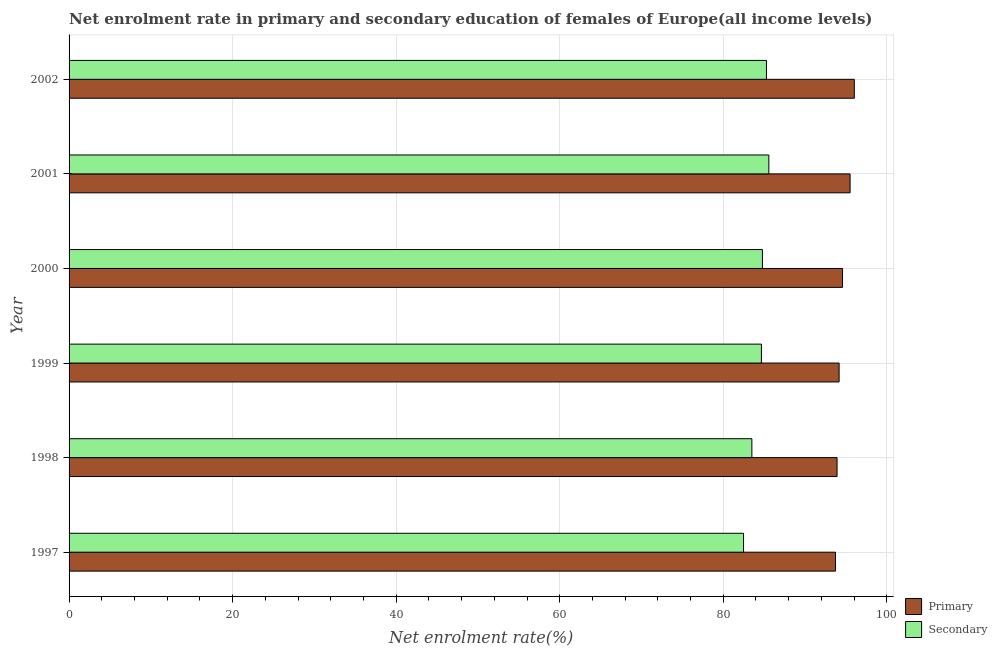How many different coloured bars are there?
Your response must be concise. 2. How many bars are there on the 4th tick from the top?
Your response must be concise. 2. In how many cases, is the number of bars for a given year not equal to the number of legend labels?
Your answer should be very brief. 0. What is the enrollment rate in secondary education in 2001?
Your answer should be compact. 85.58. Across all years, what is the maximum enrollment rate in primary education?
Make the answer very short. 96.03. Across all years, what is the minimum enrollment rate in primary education?
Make the answer very short. 93.73. In which year was the enrollment rate in primary education maximum?
Your answer should be compact. 2002. What is the total enrollment rate in primary education in the graph?
Offer a very short reply. 567.94. What is the difference between the enrollment rate in secondary education in 1997 and that in 1998?
Your answer should be very brief. -1.02. What is the difference between the enrollment rate in secondary education in 2001 and the enrollment rate in primary education in 1997?
Make the answer very short. -8.15. What is the average enrollment rate in secondary education per year?
Your answer should be very brief. 84.38. In the year 1997, what is the difference between the enrollment rate in secondary education and enrollment rate in primary education?
Your response must be concise. -11.24. What is the ratio of the enrollment rate in secondary education in 1999 to that in 2002?
Keep it short and to the point. 0.99. What is the difference between the highest and the second highest enrollment rate in primary education?
Provide a short and direct response. 0.52. What is the difference between the highest and the lowest enrollment rate in secondary education?
Make the answer very short. 3.09. In how many years, is the enrollment rate in primary education greater than the average enrollment rate in primary education taken over all years?
Your answer should be compact. 2. Is the sum of the enrollment rate in secondary education in 2000 and 2001 greater than the maximum enrollment rate in primary education across all years?
Make the answer very short. Yes. What does the 2nd bar from the top in 1997 represents?
Provide a succinct answer. Primary. What does the 2nd bar from the bottom in 2001 represents?
Provide a succinct answer. Secondary. How many bars are there?
Make the answer very short. 12. Are all the bars in the graph horizontal?
Your answer should be compact. Yes. How are the legend labels stacked?
Give a very brief answer. Vertical. What is the title of the graph?
Provide a succinct answer. Net enrolment rate in primary and secondary education of females of Europe(all income levels). What is the label or title of the X-axis?
Keep it short and to the point. Net enrolment rate(%). What is the Net enrolment rate(%) of Primary in 1997?
Offer a terse response. 93.73. What is the Net enrolment rate(%) of Secondary in 1997?
Your response must be concise. 82.48. What is the Net enrolment rate(%) in Primary in 1998?
Offer a very short reply. 93.92. What is the Net enrolment rate(%) in Secondary in 1998?
Make the answer very short. 83.5. What is the Net enrolment rate(%) of Primary in 1999?
Give a very brief answer. 94.17. What is the Net enrolment rate(%) of Secondary in 1999?
Ensure brevity in your answer.  84.67. What is the Net enrolment rate(%) in Primary in 2000?
Make the answer very short. 94.59. What is the Net enrolment rate(%) in Secondary in 2000?
Make the answer very short. 84.79. What is the Net enrolment rate(%) in Primary in 2001?
Your answer should be very brief. 95.51. What is the Net enrolment rate(%) of Secondary in 2001?
Give a very brief answer. 85.58. What is the Net enrolment rate(%) of Primary in 2002?
Offer a terse response. 96.03. What is the Net enrolment rate(%) in Secondary in 2002?
Your response must be concise. 85.29. Across all years, what is the maximum Net enrolment rate(%) in Primary?
Ensure brevity in your answer.  96.03. Across all years, what is the maximum Net enrolment rate(%) of Secondary?
Keep it short and to the point. 85.58. Across all years, what is the minimum Net enrolment rate(%) in Primary?
Provide a succinct answer. 93.73. Across all years, what is the minimum Net enrolment rate(%) in Secondary?
Offer a terse response. 82.48. What is the total Net enrolment rate(%) of Primary in the graph?
Offer a very short reply. 567.94. What is the total Net enrolment rate(%) of Secondary in the graph?
Offer a very short reply. 506.3. What is the difference between the Net enrolment rate(%) of Primary in 1997 and that in 1998?
Offer a very short reply. -0.19. What is the difference between the Net enrolment rate(%) of Secondary in 1997 and that in 1998?
Provide a succinct answer. -1.02. What is the difference between the Net enrolment rate(%) of Primary in 1997 and that in 1999?
Offer a terse response. -0.44. What is the difference between the Net enrolment rate(%) in Secondary in 1997 and that in 1999?
Your answer should be very brief. -2.19. What is the difference between the Net enrolment rate(%) of Primary in 1997 and that in 2000?
Keep it short and to the point. -0.86. What is the difference between the Net enrolment rate(%) in Secondary in 1997 and that in 2000?
Your answer should be compact. -2.31. What is the difference between the Net enrolment rate(%) in Primary in 1997 and that in 2001?
Offer a very short reply. -1.78. What is the difference between the Net enrolment rate(%) of Secondary in 1997 and that in 2001?
Offer a terse response. -3.09. What is the difference between the Net enrolment rate(%) in Primary in 1997 and that in 2002?
Provide a succinct answer. -2.3. What is the difference between the Net enrolment rate(%) of Secondary in 1997 and that in 2002?
Your answer should be compact. -2.8. What is the difference between the Net enrolment rate(%) of Primary in 1998 and that in 1999?
Your answer should be compact. -0.25. What is the difference between the Net enrolment rate(%) in Secondary in 1998 and that in 1999?
Ensure brevity in your answer.  -1.17. What is the difference between the Net enrolment rate(%) in Primary in 1998 and that in 2000?
Your answer should be very brief. -0.67. What is the difference between the Net enrolment rate(%) of Secondary in 1998 and that in 2000?
Your answer should be compact. -1.29. What is the difference between the Net enrolment rate(%) of Primary in 1998 and that in 2001?
Ensure brevity in your answer.  -1.59. What is the difference between the Net enrolment rate(%) in Secondary in 1998 and that in 2001?
Ensure brevity in your answer.  -2.08. What is the difference between the Net enrolment rate(%) in Primary in 1998 and that in 2002?
Give a very brief answer. -2.11. What is the difference between the Net enrolment rate(%) of Secondary in 1998 and that in 2002?
Your response must be concise. -1.79. What is the difference between the Net enrolment rate(%) in Primary in 1999 and that in 2000?
Give a very brief answer. -0.42. What is the difference between the Net enrolment rate(%) of Secondary in 1999 and that in 2000?
Your answer should be compact. -0.12. What is the difference between the Net enrolment rate(%) in Primary in 1999 and that in 2001?
Keep it short and to the point. -1.34. What is the difference between the Net enrolment rate(%) in Secondary in 1999 and that in 2001?
Offer a terse response. -0.91. What is the difference between the Net enrolment rate(%) of Primary in 1999 and that in 2002?
Your answer should be compact. -1.86. What is the difference between the Net enrolment rate(%) of Secondary in 1999 and that in 2002?
Offer a terse response. -0.62. What is the difference between the Net enrolment rate(%) of Primary in 2000 and that in 2001?
Provide a short and direct response. -0.93. What is the difference between the Net enrolment rate(%) in Secondary in 2000 and that in 2001?
Your answer should be compact. -0.79. What is the difference between the Net enrolment rate(%) in Primary in 2000 and that in 2002?
Offer a very short reply. -1.44. What is the difference between the Net enrolment rate(%) of Secondary in 2000 and that in 2002?
Give a very brief answer. -0.5. What is the difference between the Net enrolment rate(%) of Primary in 2001 and that in 2002?
Keep it short and to the point. -0.52. What is the difference between the Net enrolment rate(%) in Secondary in 2001 and that in 2002?
Ensure brevity in your answer.  0.29. What is the difference between the Net enrolment rate(%) of Primary in 1997 and the Net enrolment rate(%) of Secondary in 1998?
Provide a succinct answer. 10.23. What is the difference between the Net enrolment rate(%) in Primary in 1997 and the Net enrolment rate(%) in Secondary in 1999?
Give a very brief answer. 9.06. What is the difference between the Net enrolment rate(%) in Primary in 1997 and the Net enrolment rate(%) in Secondary in 2000?
Make the answer very short. 8.94. What is the difference between the Net enrolment rate(%) in Primary in 1997 and the Net enrolment rate(%) in Secondary in 2001?
Your answer should be very brief. 8.15. What is the difference between the Net enrolment rate(%) of Primary in 1997 and the Net enrolment rate(%) of Secondary in 2002?
Your response must be concise. 8.44. What is the difference between the Net enrolment rate(%) in Primary in 1998 and the Net enrolment rate(%) in Secondary in 1999?
Your response must be concise. 9.25. What is the difference between the Net enrolment rate(%) in Primary in 1998 and the Net enrolment rate(%) in Secondary in 2000?
Give a very brief answer. 9.13. What is the difference between the Net enrolment rate(%) of Primary in 1998 and the Net enrolment rate(%) of Secondary in 2001?
Give a very brief answer. 8.34. What is the difference between the Net enrolment rate(%) in Primary in 1998 and the Net enrolment rate(%) in Secondary in 2002?
Ensure brevity in your answer.  8.63. What is the difference between the Net enrolment rate(%) in Primary in 1999 and the Net enrolment rate(%) in Secondary in 2000?
Make the answer very short. 9.38. What is the difference between the Net enrolment rate(%) of Primary in 1999 and the Net enrolment rate(%) of Secondary in 2001?
Make the answer very short. 8.59. What is the difference between the Net enrolment rate(%) in Primary in 1999 and the Net enrolment rate(%) in Secondary in 2002?
Offer a terse response. 8.88. What is the difference between the Net enrolment rate(%) of Primary in 2000 and the Net enrolment rate(%) of Secondary in 2001?
Keep it short and to the point. 9.01. What is the difference between the Net enrolment rate(%) of Primary in 2000 and the Net enrolment rate(%) of Secondary in 2002?
Ensure brevity in your answer.  9.3. What is the difference between the Net enrolment rate(%) in Primary in 2001 and the Net enrolment rate(%) in Secondary in 2002?
Provide a short and direct response. 10.23. What is the average Net enrolment rate(%) of Primary per year?
Your answer should be very brief. 94.66. What is the average Net enrolment rate(%) in Secondary per year?
Offer a very short reply. 84.38. In the year 1997, what is the difference between the Net enrolment rate(%) in Primary and Net enrolment rate(%) in Secondary?
Your response must be concise. 11.25. In the year 1998, what is the difference between the Net enrolment rate(%) in Primary and Net enrolment rate(%) in Secondary?
Make the answer very short. 10.42. In the year 1999, what is the difference between the Net enrolment rate(%) in Primary and Net enrolment rate(%) in Secondary?
Provide a succinct answer. 9.5. In the year 2000, what is the difference between the Net enrolment rate(%) of Primary and Net enrolment rate(%) of Secondary?
Provide a succinct answer. 9.8. In the year 2001, what is the difference between the Net enrolment rate(%) in Primary and Net enrolment rate(%) in Secondary?
Ensure brevity in your answer.  9.94. In the year 2002, what is the difference between the Net enrolment rate(%) of Primary and Net enrolment rate(%) of Secondary?
Ensure brevity in your answer.  10.74. What is the ratio of the Net enrolment rate(%) of Primary in 1997 to that in 1999?
Provide a succinct answer. 1. What is the ratio of the Net enrolment rate(%) of Secondary in 1997 to that in 1999?
Give a very brief answer. 0.97. What is the ratio of the Net enrolment rate(%) in Primary in 1997 to that in 2000?
Give a very brief answer. 0.99. What is the ratio of the Net enrolment rate(%) of Secondary in 1997 to that in 2000?
Offer a very short reply. 0.97. What is the ratio of the Net enrolment rate(%) of Primary in 1997 to that in 2001?
Offer a terse response. 0.98. What is the ratio of the Net enrolment rate(%) in Secondary in 1997 to that in 2001?
Your response must be concise. 0.96. What is the ratio of the Net enrolment rate(%) in Primary in 1997 to that in 2002?
Your answer should be very brief. 0.98. What is the ratio of the Net enrolment rate(%) in Secondary in 1997 to that in 2002?
Offer a terse response. 0.97. What is the ratio of the Net enrolment rate(%) of Secondary in 1998 to that in 1999?
Provide a short and direct response. 0.99. What is the ratio of the Net enrolment rate(%) of Primary in 1998 to that in 2000?
Give a very brief answer. 0.99. What is the ratio of the Net enrolment rate(%) of Secondary in 1998 to that in 2000?
Provide a succinct answer. 0.98. What is the ratio of the Net enrolment rate(%) in Primary in 1998 to that in 2001?
Offer a terse response. 0.98. What is the ratio of the Net enrolment rate(%) in Secondary in 1998 to that in 2001?
Your answer should be very brief. 0.98. What is the ratio of the Net enrolment rate(%) of Primary in 1998 to that in 2002?
Ensure brevity in your answer.  0.98. What is the ratio of the Net enrolment rate(%) of Secondary in 1998 to that in 2002?
Provide a short and direct response. 0.98. What is the ratio of the Net enrolment rate(%) in Secondary in 1999 to that in 2000?
Make the answer very short. 1. What is the ratio of the Net enrolment rate(%) of Primary in 1999 to that in 2001?
Provide a short and direct response. 0.99. What is the ratio of the Net enrolment rate(%) in Secondary in 1999 to that in 2001?
Your response must be concise. 0.99. What is the ratio of the Net enrolment rate(%) of Primary in 1999 to that in 2002?
Make the answer very short. 0.98. What is the ratio of the Net enrolment rate(%) in Primary in 2000 to that in 2001?
Provide a succinct answer. 0.99. What is the ratio of the Net enrolment rate(%) of Secondary in 2000 to that in 2002?
Offer a terse response. 0.99. What is the difference between the highest and the second highest Net enrolment rate(%) of Primary?
Give a very brief answer. 0.52. What is the difference between the highest and the second highest Net enrolment rate(%) in Secondary?
Ensure brevity in your answer.  0.29. What is the difference between the highest and the lowest Net enrolment rate(%) of Primary?
Your response must be concise. 2.3. What is the difference between the highest and the lowest Net enrolment rate(%) of Secondary?
Make the answer very short. 3.09. 